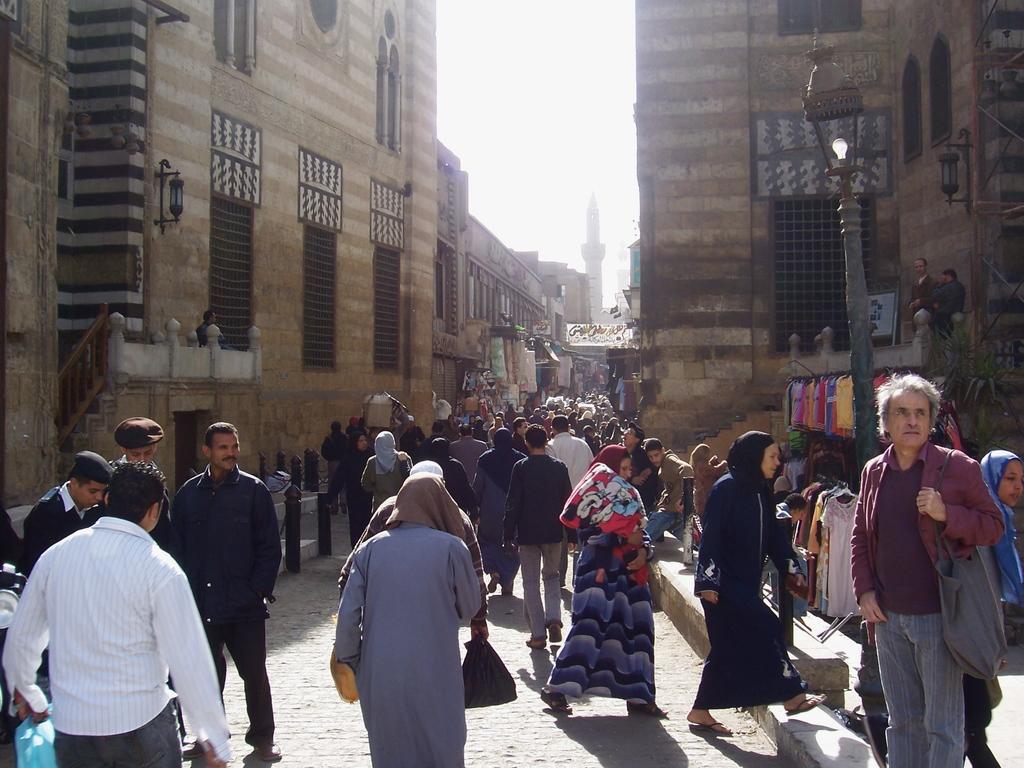Please provide a concise description of this image. In this image we can see a group of people standing on the ground. One person is holding a bag with his hand. On the right side of the image we can see a group of clothes on hangers, light pole and some metal poles. In the center of the image we can see cardboard box. On the left side, we can see staircase. In the background, we can see buildings with windows, lights, a tower and the sky. 